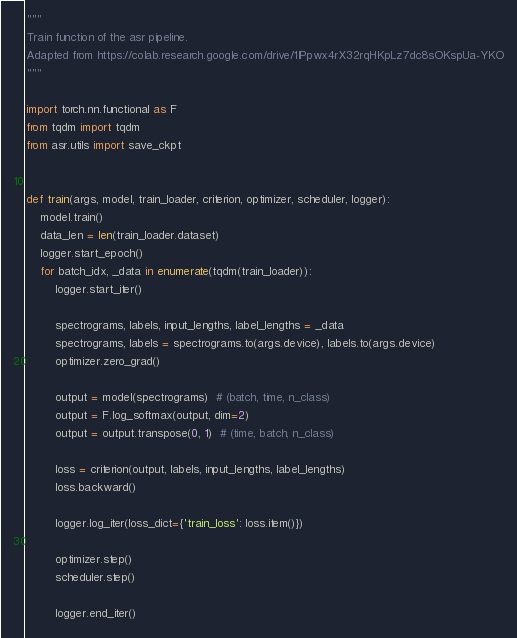Convert code to text. <code><loc_0><loc_0><loc_500><loc_500><_Python_>"""
Train function of the asr pipeline.
Adapted from https://colab.research.google.com/drive/1IPpwx4rX32rqHKpLz7dc8sOKspUa-YKO
"""

import torch.nn.functional as F
from tqdm import tqdm
from asr.utils import save_ckpt


def train(args, model, train_loader, criterion, optimizer, scheduler, logger):
    model.train()
    data_len = len(train_loader.dataset)
    logger.start_epoch()
    for batch_idx, _data in enumerate(tqdm(train_loader)):
        logger.start_iter()

        spectrograms, labels, input_lengths, label_lengths = _data
        spectrograms, labels = spectrograms.to(args.device), labels.to(args.device)
        optimizer.zero_grad()

        output = model(spectrograms)  # (batch, time, n_class)
        output = F.log_softmax(output, dim=2)
        output = output.transpose(0, 1)  # (time, batch, n_class)

        loss = criterion(output, labels, input_lengths, label_lengths)
        loss.backward()

        logger.log_iter(loss_dict={'train_loss': loss.item()})

        optimizer.step()
        scheduler.step()

        logger.end_iter()
</code> 